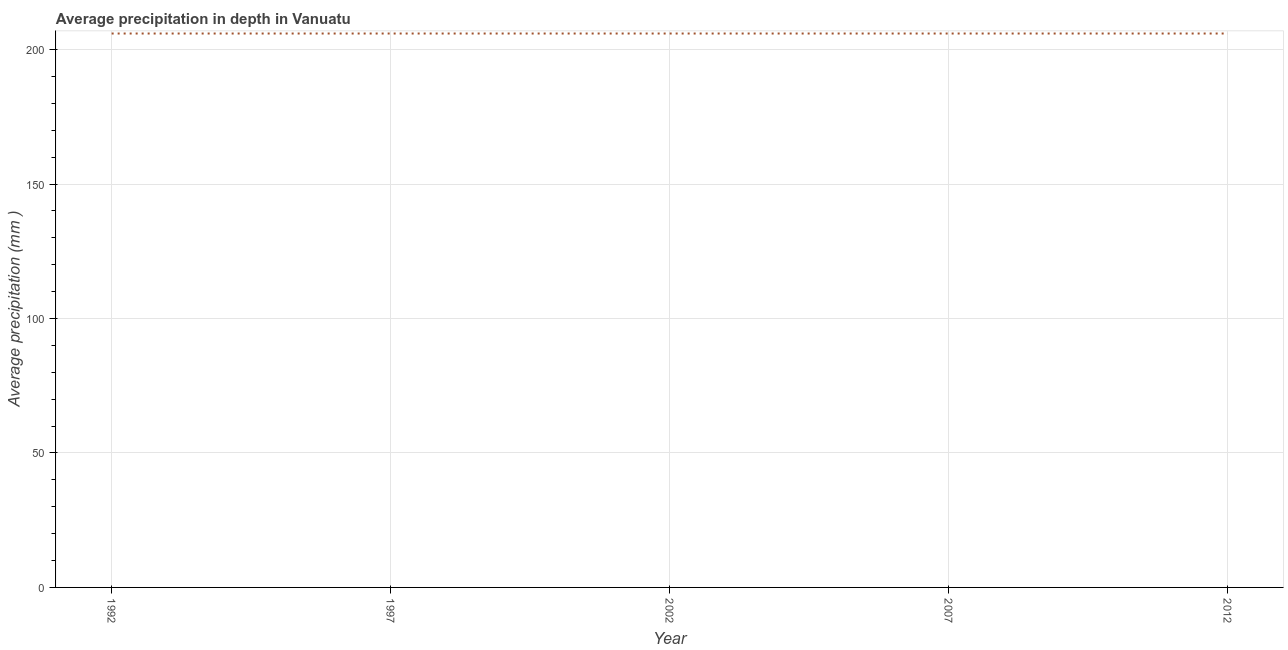What is the average precipitation in depth in 1997?
Ensure brevity in your answer.  206. Across all years, what is the maximum average precipitation in depth?
Keep it short and to the point. 206. Across all years, what is the minimum average precipitation in depth?
Ensure brevity in your answer.  206. What is the sum of the average precipitation in depth?
Your answer should be very brief. 1030. What is the difference between the average precipitation in depth in 1992 and 2002?
Your response must be concise. 0. What is the average average precipitation in depth per year?
Your answer should be compact. 206. What is the median average precipitation in depth?
Ensure brevity in your answer.  206. In how many years, is the average precipitation in depth greater than 90 mm?
Your response must be concise. 5. Do a majority of the years between 2007 and 1992 (inclusive) have average precipitation in depth greater than 180 mm?
Make the answer very short. Yes. Is the average precipitation in depth in 2002 less than that in 2012?
Offer a very short reply. No. Is the difference between the average precipitation in depth in 1992 and 2002 greater than the difference between any two years?
Keep it short and to the point. Yes. What is the difference between the highest and the second highest average precipitation in depth?
Provide a short and direct response. 0. What is the difference between the highest and the lowest average precipitation in depth?
Make the answer very short. 0. How many lines are there?
Your answer should be compact. 1. How many years are there in the graph?
Offer a terse response. 5. Does the graph contain any zero values?
Offer a terse response. No. What is the title of the graph?
Make the answer very short. Average precipitation in depth in Vanuatu. What is the label or title of the X-axis?
Your response must be concise. Year. What is the label or title of the Y-axis?
Offer a terse response. Average precipitation (mm ). What is the Average precipitation (mm ) of 1992?
Ensure brevity in your answer.  206. What is the Average precipitation (mm ) of 1997?
Your response must be concise. 206. What is the Average precipitation (mm ) of 2002?
Ensure brevity in your answer.  206. What is the Average precipitation (mm ) in 2007?
Offer a very short reply. 206. What is the Average precipitation (mm ) in 2012?
Provide a succinct answer. 206. What is the difference between the Average precipitation (mm ) in 1992 and 1997?
Your answer should be very brief. 0. What is the difference between the Average precipitation (mm ) in 1992 and 2002?
Provide a succinct answer. 0. What is the difference between the Average precipitation (mm ) in 1992 and 2007?
Offer a terse response. 0. What is the difference between the Average precipitation (mm ) in 1992 and 2012?
Offer a terse response. 0. What is the difference between the Average precipitation (mm ) in 1997 and 2007?
Offer a very short reply. 0. What is the difference between the Average precipitation (mm ) in 1997 and 2012?
Make the answer very short. 0. What is the difference between the Average precipitation (mm ) in 2002 and 2012?
Your answer should be compact. 0. What is the difference between the Average precipitation (mm ) in 2007 and 2012?
Your response must be concise. 0. What is the ratio of the Average precipitation (mm ) in 1992 to that in 2002?
Your response must be concise. 1. What is the ratio of the Average precipitation (mm ) in 1992 to that in 2007?
Ensure brevity in your answer.  1. What is the ratio of the Average precipitation (mm ) in 1992 to that in 2012?
Provide a succinct answer. 1. What is the ratio of the Average precipitation (mm ) in 1997 to that in 2012?
Offer a very short reply. 1. What is the ratio of the Average precipitation (mm ) in 2007 to that in 2012?
Provide a succinct answer. 1. 